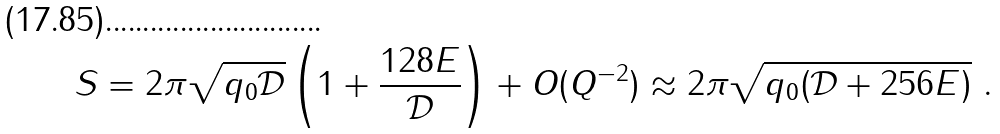Convert formula to latex. <formula><loc_0><loc_0><loc_500><loc_500>S = 2 \pi \sqrt { q _ { 0 } \mathcal { D } } \left ( 1 + \frac { 1 2 8 E } { \mathcal { D } } \right ) + O ( Q ^ { - 2 } ) \approx 2 \pi \sqrt { q _ { 0 } ( \mathcal { D } + 2 5 6 E ) } \ .</formula> 